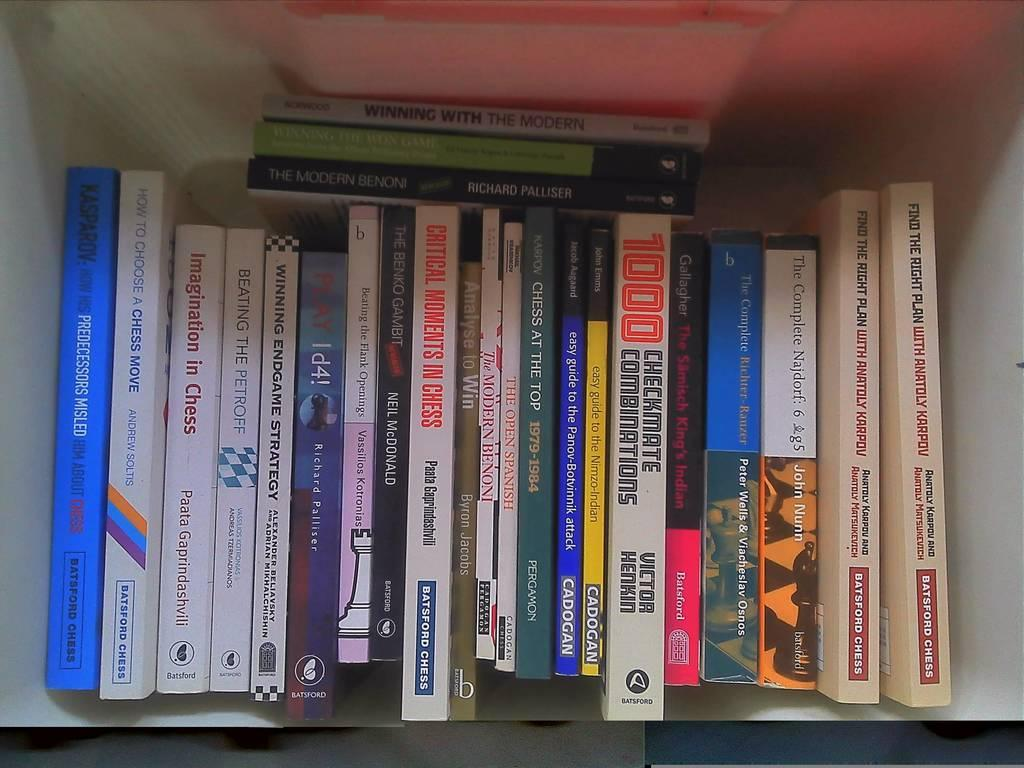<image>
Offer a succinct explanation of the picture presented. A group of books with at least one being about checkmate combinations. 